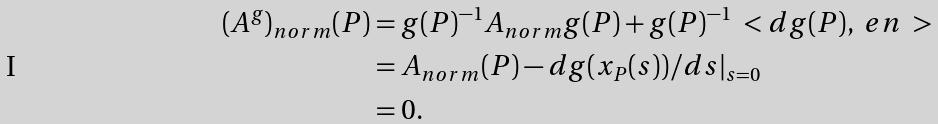<formula> <loc_0><loc_0><loc_500><loc_500>( A ^ { g } ) _ { n o r m } ( P ) & = g ( P ) ^ { - 1 } A _ { n o r m } g ( P ) + g ( P ) ^ { - 1 } \ < d g ( P ) , \ e n \ > \\ & = A _ { n o r m } ( P ) - d g ( x _ { P } ( s ) ) / d s | _ { s = 0 } \\ & = 0 .</formula> 